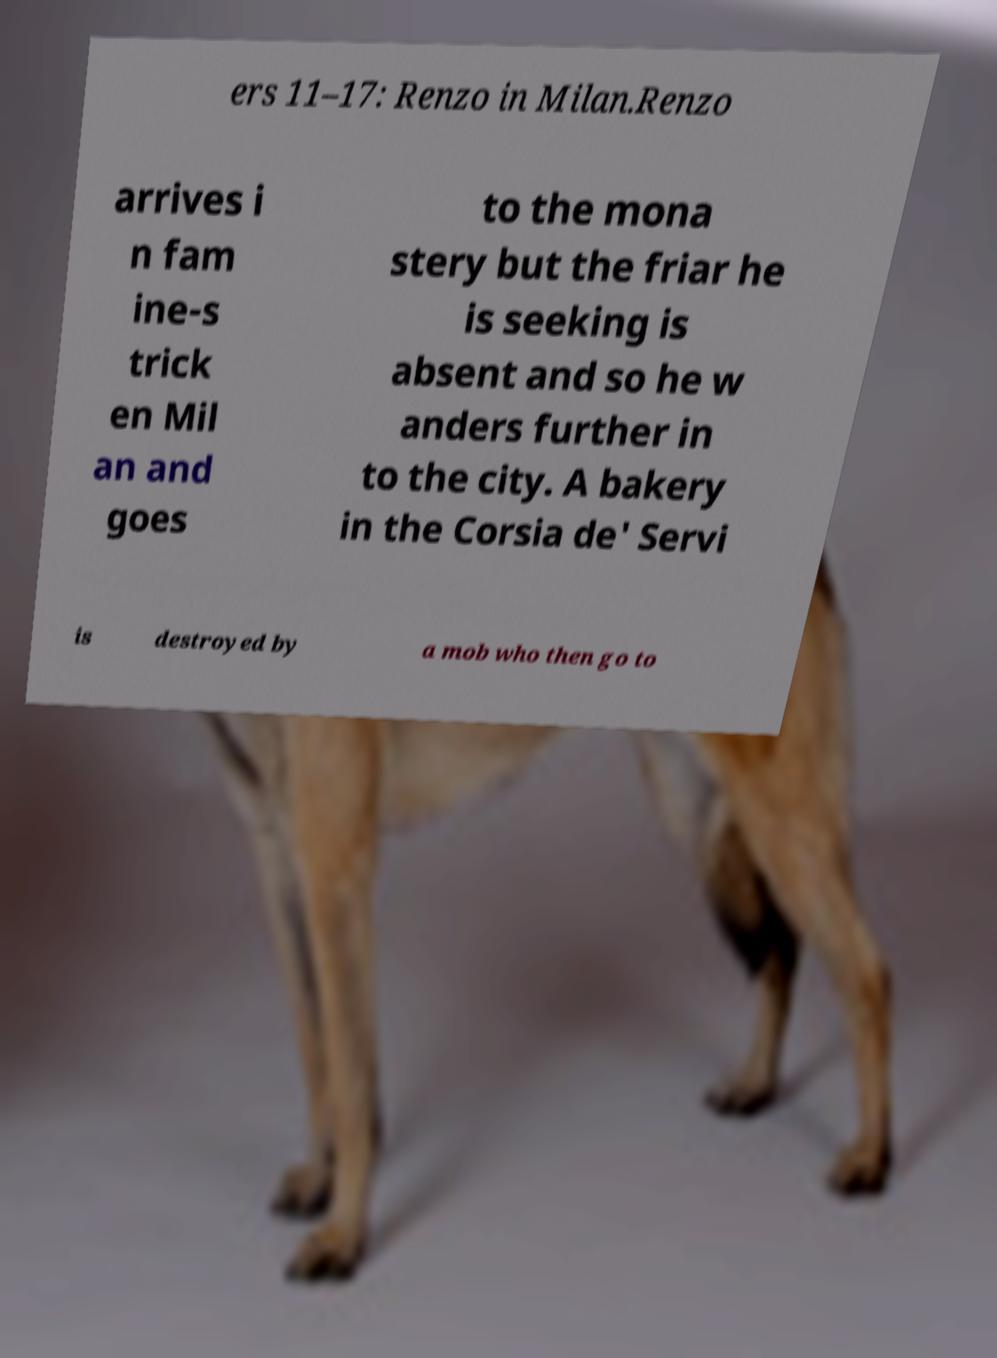Can you accurately transcribe the text from the provided image for me? ers 11–17: Renzo in Milan.Renzo arrives i n fam ine-s trick en Mil an and goes to the mona stery but the friar he is seeking is absent and so he w anders further in to the city. A bakery in the Corsia de' Servi is destroyed by a mob who then go to 